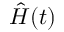Convert formula to latex. <formula><loc_0><loc_0><loc_500><loc_500>\hat { H } ( t )</formula> 